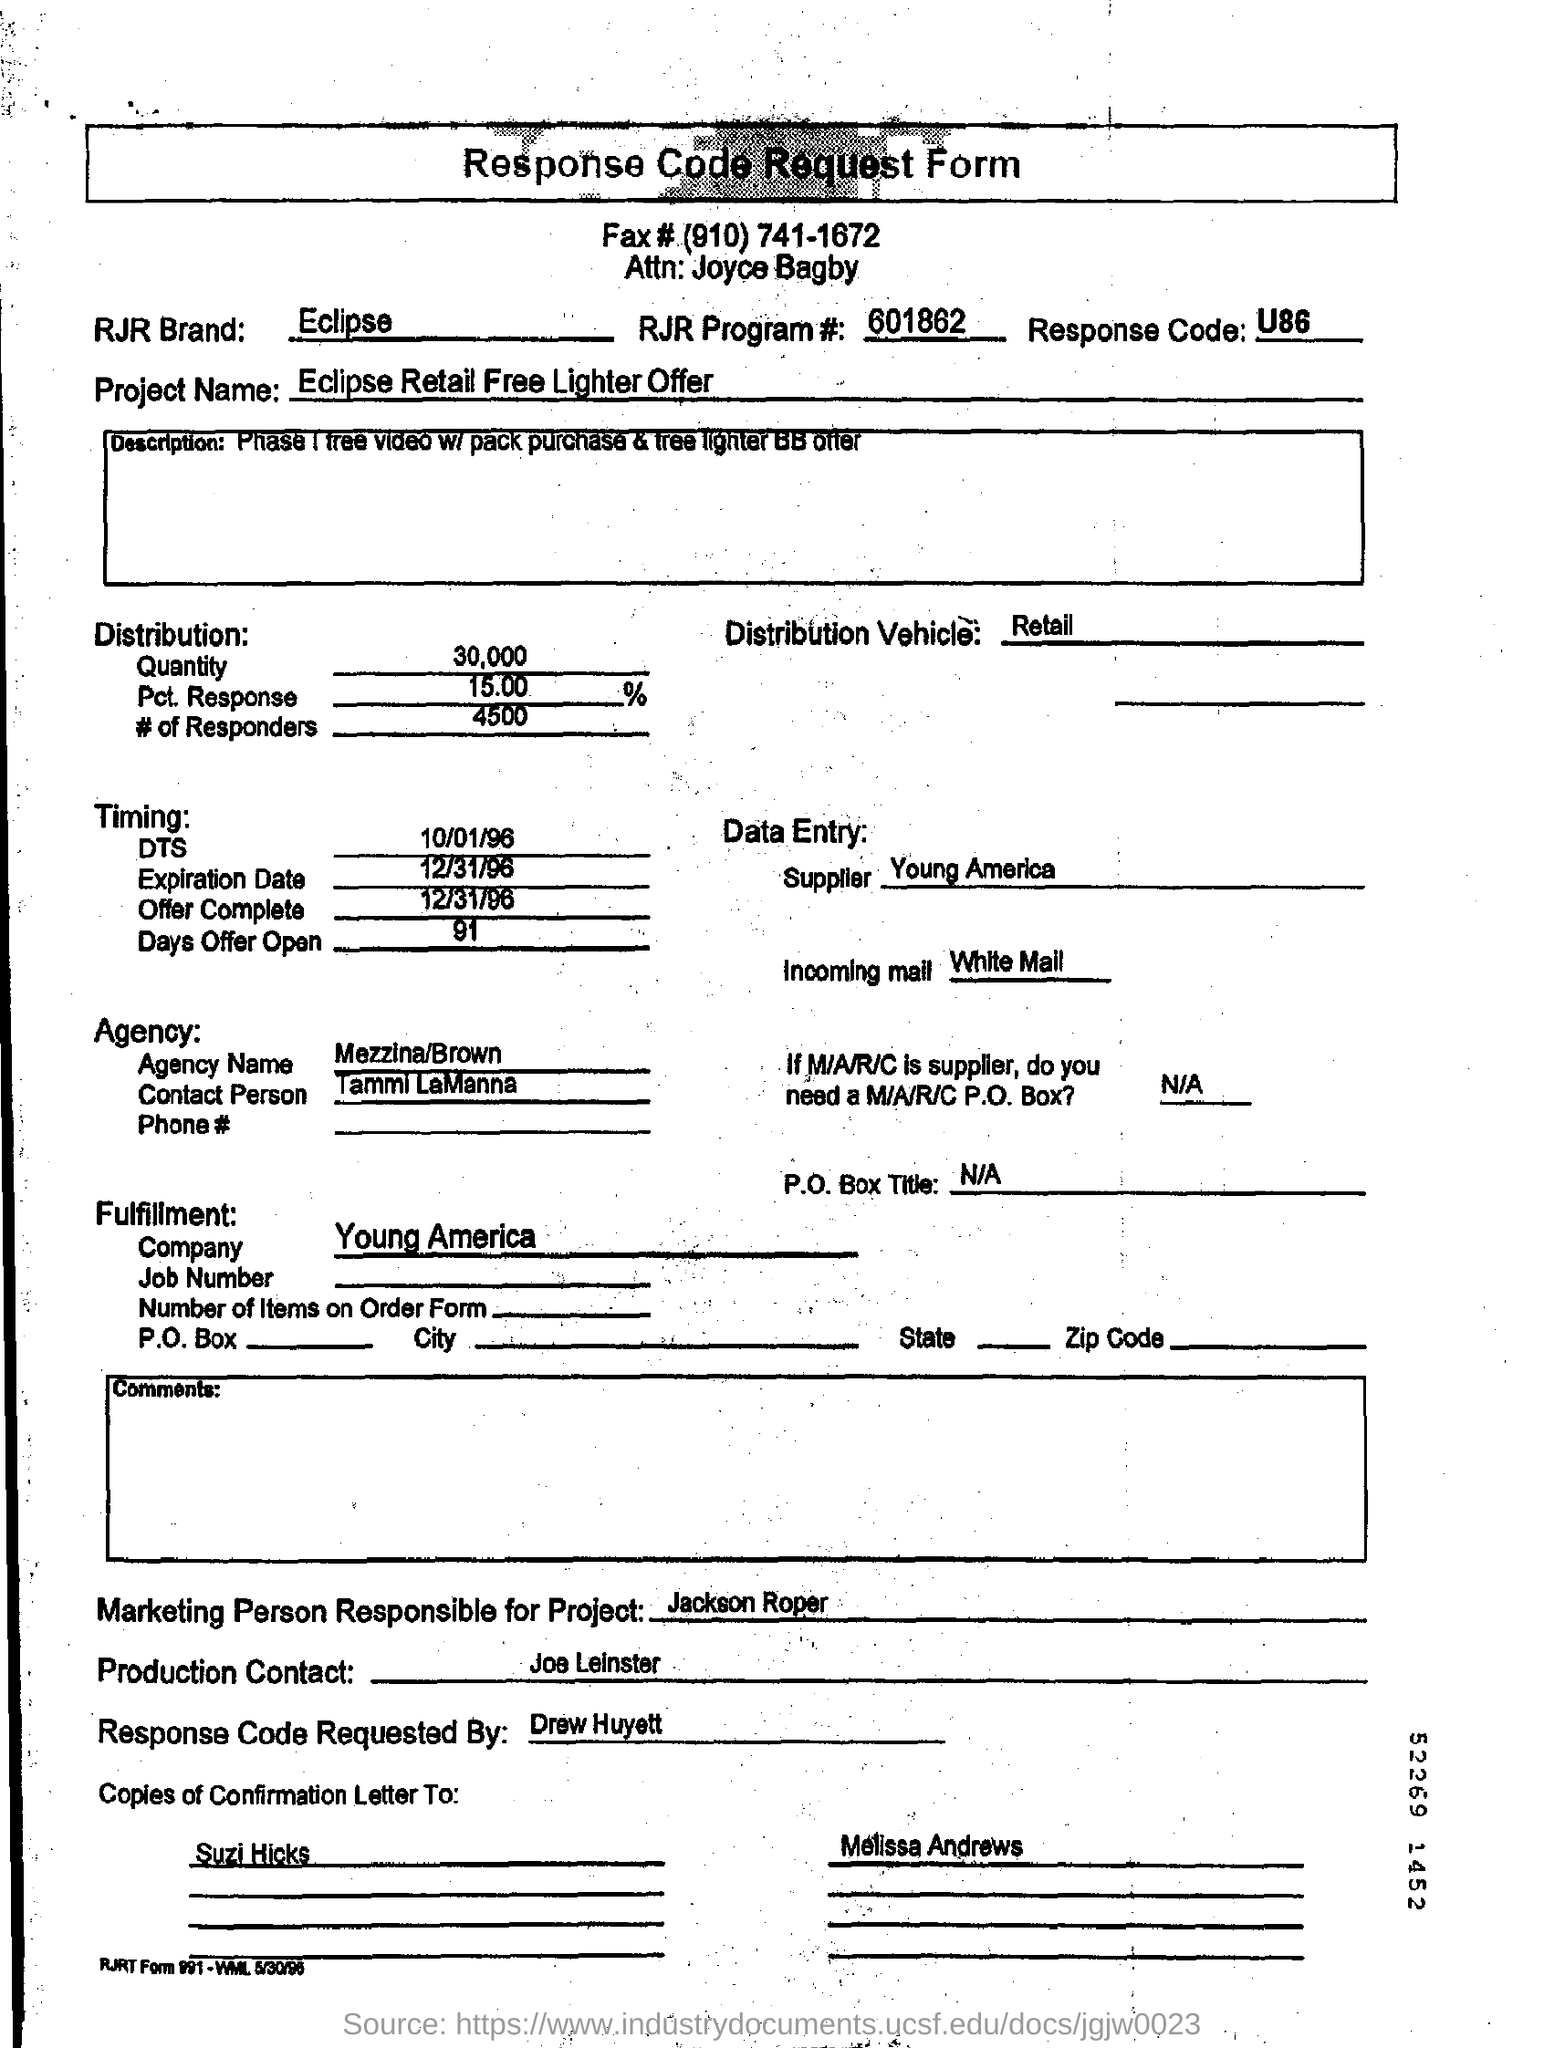What is the RJR Program #?
 601862 